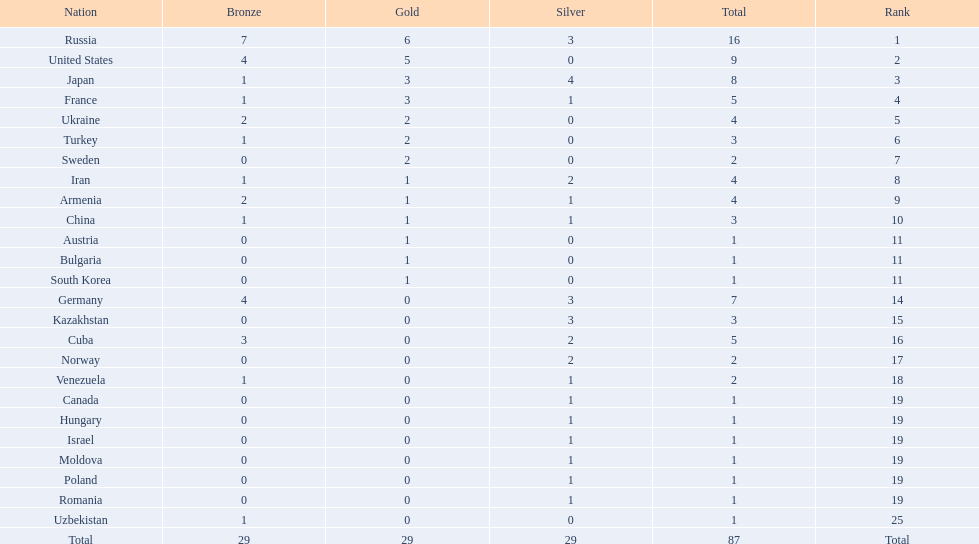Where did iran rank? 8. Where did germany rank? 14. Which of those did make it into the top 10 rank? Germany. 